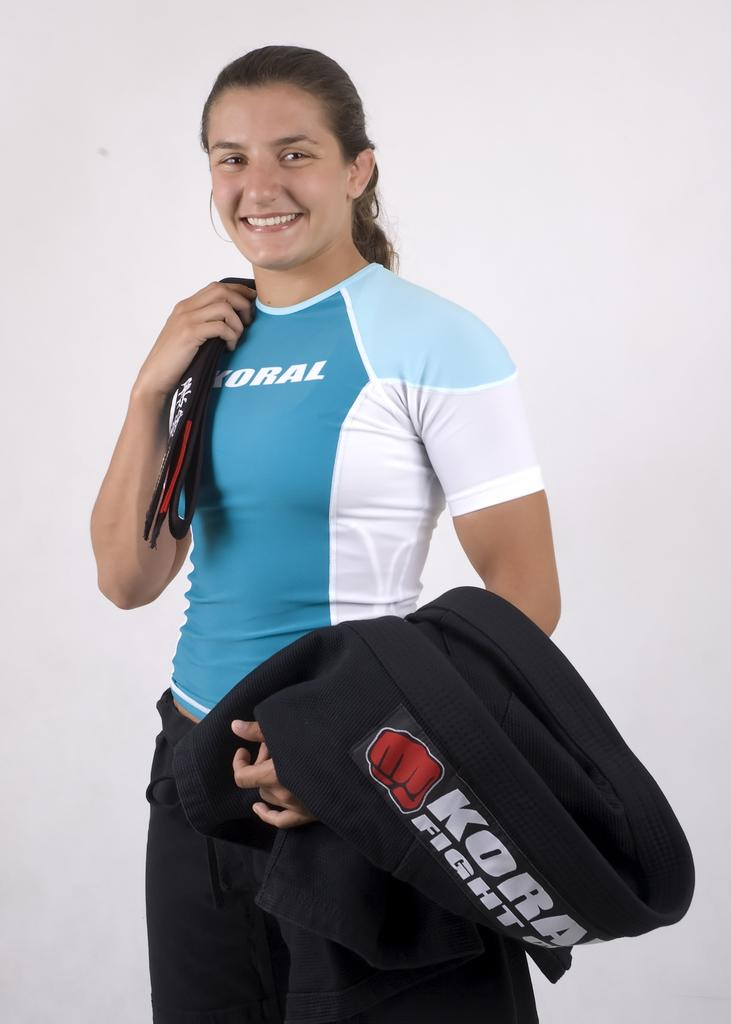<image>
Share a concise interpretation of the image provided. A person wearing a teal shirt with the word Koral on the front 